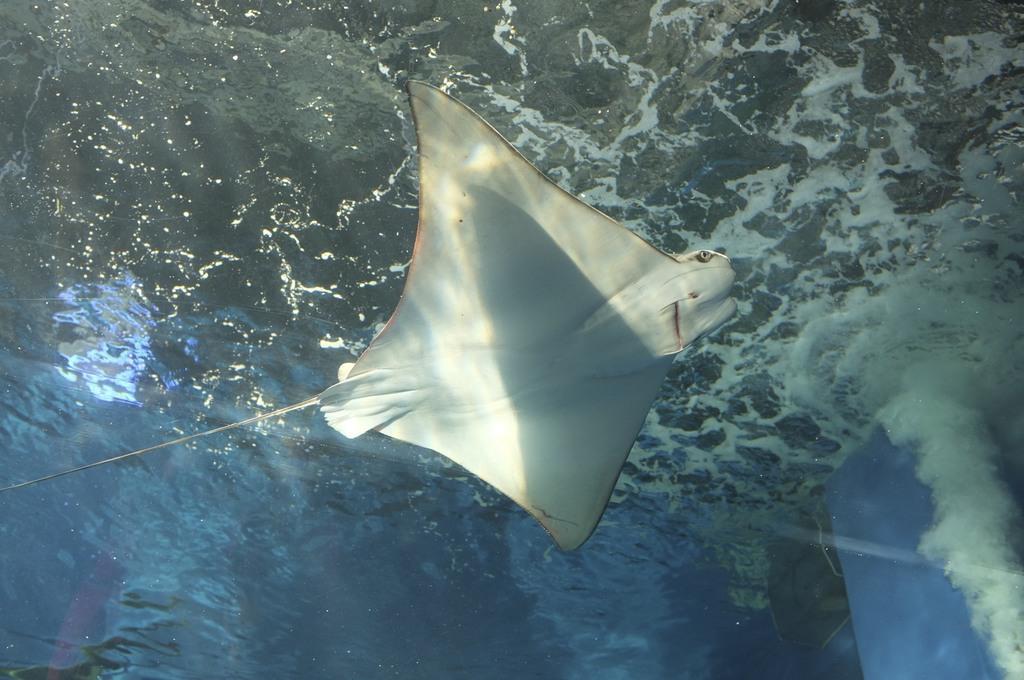How would you summarize this image in a sentence or two? In the image we can see there is an aquatic animal skate in the water. 